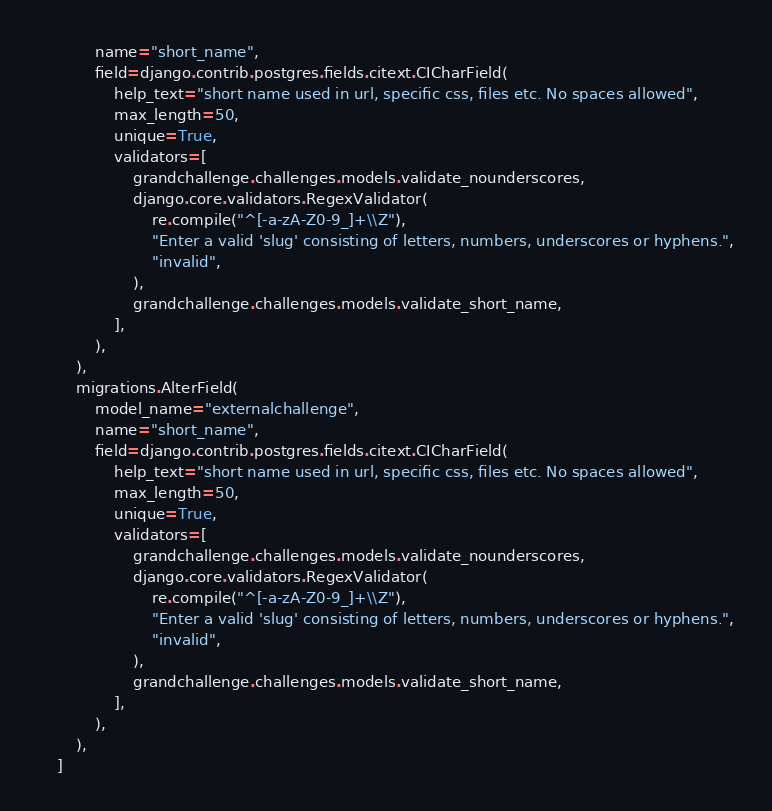Convert code to text. <code><loc_0><loc_0><loc_500><loc_500><_Python_>            name="short_name",
            field=django.contrib.postgres.fields.citext.CICharField(
                help_text="short name used in url, specific css, files etc. No spaces allowed",
                max_length=50,
                unique=True,
                validators=[
                    grandchallenge.challenges.models.validate_nounderscores,
                    django.core.validators.RegexValidator(
                        re.compile("^[-a-zA-Z0-9_]+\\Z"),
                        "Enter a valid 'slug' consisting of letters, numbers, underscores or hyphens.",
                        "invalid",
                    ),
                    grandchallenge.challenges.models.validate_short_name,
                ],
            ),
        ),
        migrations.AlterField(
            model_name="externalchallenge",
            name="short_name",
            field=django.contrib.postgres.fields.citext.CICharField(
                help_text="short name used in url, specific css, files etc. No spaces allowed",
                max_length=50,
                unique=True,
                validators=[
                    grandchallenge.challenges.models.validate_nounderscores,
                    django.core.validators.RegexValidator(
                        re.compile("^[-a-zA-Z0-9_]+\\Z"),
                        "Enter a valid 'slug' consisting of letters, numbers, underscores or hyphens.",
                        "invalid",
                    ),
                    grandchallenge.challenges.models.validate_short_name,
                ],
            ),
        ),
    ]
</code> 